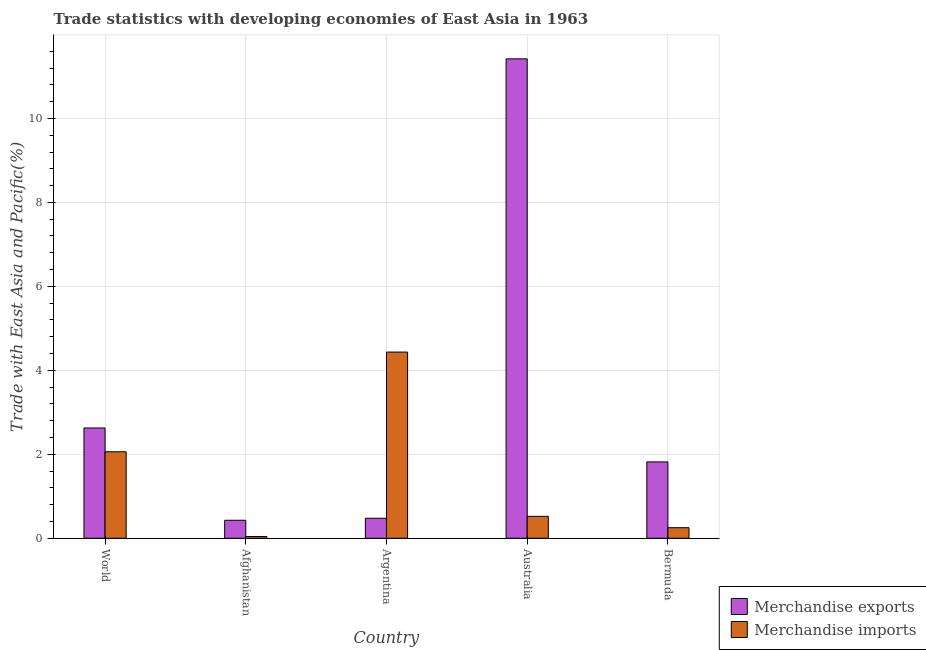How many groups of bars are there?
Offer a very short reply. 5. Are the number of bars on each tick of the X-axis equal?
Give a very brief answer. Yes. How many bars are there on the 2nd tick from the left?
Ensure brevity in your answer.  2. What is the label of the 2nd group of bars from the left?
Offer a terse response. Afghanistan. In how many cases, is the number of bars for a given country not equal to the number of legend labels?
Provide a short and direct response. 0. What is the merchandise imports in World?
Your answer should be compact. 2.06. Across all countries, what is the maximum merchandise exports?
Offer a terse response. 11.42. Across all countries, what is the minimum merchandise imports?
Ensure brevity in your answer.  0.04. In which country was the merchandise imports maximum?
Give a very brief answer. Argentina. In which country was the merchandise exports minimum?
Offer a terse response. Afghanistan. What is the total merchandise exports in the graph?
Your answer should be compact. 16.77. What is the difference between the merchandise imports in Afghanistan and that in Australia?
Your answer should be compact. -0.48. What is the difference between the merchandise exports in Australia and the merchandise imports in World?
Make the answer very short. 9.36. What is the average merchandise exports per country?
Offer a terse response. 3.35. What is the difference between the merchandise exports and merchandise imports in Bermuda?
Your response must be concise. 1.57. In how many countries, is the merchandise exports greater than 8 %?
Offer a terse response. 1. What is the ratio of the merchandise imports in Australia to that in World?
Your response must be concise. 0.25. Is the difference between the merchandise exports in Australia and World greater than the difference between the merchandise imports in Australia and World?
Your answer should be very brief. Yes. What is the difference between the highest and the second highest merchandise imports?
Offer a terse response. 2.38. What is the difference between the highest and the lowest merchandise exports?
Provide a short and direct response. 10.99. Is the sum of the merchandise imports in Australia and World greater than the maximum merchandise exports across all countries?
Make the answer very short. No. What does the 2nd bar from the right in Argentina represents?
Your response must be concise. Merchandise exports. Are all the bars in the graph horizontal?
Your answer should be very brief. No. How many countries are there in the graph?
Your answer should be very brief. 5. What is the difference between two consecutive major ticks on the Y-axis?
Your answer should be compact. 2. Does the graph contain grids?
Your answer should be compact. Yes. Where does the legend appear in the graph?
Ensure brevity in your answer.  Bottom right. How many legend labels are there?
Give a very brief answer. 2. What is the title of the graph?
Your answer should be very brief. Trade statistics with developing economies of East Asia in 1963. What is the label or title of the X-axis?
Ensure brevity in your answer.  Country. What is the label or title of the Y-axis?
Offer a terse response. Trade with East Asia and Pacific(%). What is the Trade with East Asia and Pacific(%) of Merchandise exports in World?
Make the answer very short. 2.63. What is the Trade with East Asia and Pacific(%) in Merchandise imports in World?
Offer a very short reply. 2.06. What is the Trade with East Asia and Pacific(%) of Merchandise exports in Afghanistan?
Offer a terse response. 0.43. What is the Trade with East Asia and Pacific(%) in Merchandise imports in Afghanistan?
Provide a short and direct response. 0.04. What is the Trade with East Asia and Pacific(%) of Merchandise exports in Argentina?
Keep it short and to the point. 0.48. What is the Trade with East Asia and Pacific(%) in Merchandise imports in Argentina?
Keep it short and to the point. 4.43. What is the Trade with East Asia and Pacific(%) in Merchandise exports in Australia?
Offer a terse response. 11.42. What is the Trade with East Asia and Pacific(%) of Merchandise imports in Australia?
Your response must be concise. 0.52. What is the Trade with East Asia and Pacific(%) in Merchandise exports in Bermuda?
Provide a succinct answer. 1.82. What is the Trade with East Asia and Pacific(%) in Merchandise imports in Bermuda?
Offer a terse response. 0.25. Across all countries, what is the maximum Trade with East Asia and Pacific(%) of Merchandise exports?
Ensure brevity in your answer.  11.42. Across all countries, what is the maximum Trade with East Asia and Pacific(%) of Merchandise imports?
Your answer should be very brief. 4.43. Across all countries, what is the minimum Trade with East Asia and Pacific(%) in Merchandise exports?
Your answer should be compact. 0.43. Across all countries, what is the minimum Trade with East Asia and Pacific(%) in Merchandise imports?
Your response must be concise. 0.04. What is the total Trade with East Asia and Pacific(%) in Merchandise exports in the graph?
Ensure brevity in your answer.  16.77. What is the total Trade with East Asia and Pacific(%) of Merchandise imports in the graph?
Your answer should be compact. 7.31. What is the difference between the Trade with East Asia and Pacific(%) of Merchandise exports in World and that in Afghanistan?
Your answer should be compact. 2.2. What is the difference between the Trade with East Asia and Pacific(%) of Merchandise imports in World and that in Afghanistan?
Give a very brief answer. 2.02. What is the difference between the Trade with East Asia and Pacific(%) in Merchandise exports in World and that in Argentina?
Offer a terse response. 2.15. What is the difference between the Trade with East Asia and Pacific(%) in Merchandise imports in World and that in Argentina?
Offer a very short reply. -2.38. What is the difference between the Trade with East Asia and Pacific(%) of Merchandise exports in World and that in Australia?
Give a very brief answer. -8.79. What is the difference between the Trade with East Asia and Pacific(%) in Merchandise imports in World and that in Australia?
Provide a short and direct response. 1.54. What is the difference between the Trade with East Asia and Pacific(%) in Merchandise exports in World and that in Bermuda?
Offer a terse response. 0.81. What is the difference between the Trade with East Asia and Pacific(%) of Merchandise imports in World and that in Bermuda?
Your response must be concise. 1.81. What is the difference between the Trade with East Asia and Pacific(%) of Merchandise exports in Afghanistan and that in Argentina?
Give a very brief answer. -0.05. What is the difference between the Trade with East Asia and Pacific(%) of Merchandise imports in Afghanistan and that in Argentina?
Your answer should be very brief. -4.39. What is the difference between the Trade with East Asia and Pacific(%) in Merchandise exports in Afghanistan and that in Australia?
Offer a terse response. -10.99. What is the difference between the Trade with East Asia and Pacific(%) in Merchandise imports in Afghanistan and that in Australia?
Ensure brevity in your answer.  -0.48. What is the difference between the Trade with East Asia and Pacific(%) of Merchandise exports in Afghanistan and that in Bermuda?
Your answer should be very brief. -1.39. What is the difference between the Trade with East Asia and Pacific(%) in Merchandise imports in Afghanistan and that in Bermuda?
Ensure brevity in your answer.  -0.21. What is the difference between the Trade with East Asia and Pacific(%) in Merchandise exports in Argentina and that in Australia?
Your answer should be compact. -10.94. What is the difference between the Trade with East Asia and Pacific(%) in Merchandise imports in Argentina and that in Australia?
Ensure brevity in your answer.  3.91. What is the difference between the Trade with East Asia and Pacific(%) of Merchandise exports in Argentina and that in Bermuda?
Your response must be concise. -1.34. What is the difference between the Trade with East Asia and Pacific(%) of Merchandise imports in Argentina and that in Bermuda?
Provide a succinct answer. 4.18. What is the difference between the Trade with East Asia and Pacific(%) of Merchandise exports in Australia and that in Bermuda?
Offer a very short reply. 9.6. What is the difference between the Trade with East Asia and Pacific(%) of Merchandise imports in Australia and that in Bermuda?
Provide a succinct answer. 0.27. What is the difference between the Trade with East Asia and Pacific(%) in Merchandise exports in World and the Trade with East Asia and Pacific(%) in Merchandise imports in Afghanistan?
Provide a succinct answer. 2.59. What is the difference between the Trade with East Asia and Pacific(%) in Merchandise exports in World and the Trade with East Asia and Pacific(%) in Merchandise imports in Argentina?
Keep it short and to the point. -1.81. What is the difference between the Trade with East Asia and Pacific(%) in Merchandise exports in World and the Trade with East Asia and Pacific(%) in Merchandise imports in Australia?
Offer a terse response. 2.1. What is the difference between the Trade with East Asia and Pacific(%) of Merchandise exports in World and the Trade with East Asia and Pacific(%) of Merchandise imports in Bermuda?
Offer a terse response. 2.38. What is the difference between the Trade with East Asia and Pacific(%) of Merchandise exports in Afghanistan and the Trade with East Asia and Pacific(%) of Merchandise imports in Argentina?
Your response must be concise. -4.01. What is the difference between the Trade with East Asia and Pacific(%) in Merchandise exports in Afghanistan and the Trade with East Asia and Pacific(%) in Merchandise imports in Australia?
Your response must be concise. -0.09. What is the difference between the Trade with East Asia and Pacific(%) of Merchandise exports in Afghanistan and the Trade with East Asia and Pacific(%) of Merchandise imports in Bermuda?
Offer a very short reply. 0.18. What is the difference between the Trade with East Asia and Pacific(%) in Merchandise exports in Argentina and the Trade with East Asia and Pacific(%) in Merchandise imports in Australia?
Your answer should be compact. -0.05. What is the difference between the Trade with East Asia and Pacific(%) of Merchandise exports in Argentina and the Trade with East Asia and Pacific(%) of Merchandise imports in Bermuda?
Your answer should be compact. 0.23. What is the difference between the Trade with East Asia and Pacific(%) in Merchandise exports in Australia and the Trade with East Asia and Pacific(%) in Merchandise imports in Bermuda?
Provide a succinct answer. 11.17. What is the average Trade with East Asia and Pacific(%) in Merchandise exports per country?
Offer a terse response. 3.35. What is the average Trade with East Asia and Pacific(%) in Merchandise imports per country?
Your answer should be very brief. 1.46. What is the difference between the Trade with East Asia and Pacific(%) of Merchandise exports and Trade with East Asia and Pacific(%) of Merchandise imports in World?
Provide a succinct answer. 0.57. What is the difference between the Trade with East Asia and Pacific(%) of Merchandise exports and Trade with East Asia and Pacific(%) of Merchandise imports in Afghanistan?
Your answer should be very brief. 0.39. What is the difference between the Trade with East Asia and Pacific(%) in Merchandise exports and Trade with East Asia and Pacific(%) in Merchandise imports in Argentina?
Offer a very short reply. -3.96. What is the difference between the Trade with East Asia and Pacific(%) in Merchandise exports and Trade with East Asia and Pacific(%) in Merchandise imports in Australia?
Keep it short and to the point. 10.9. What is the difference between the Trade with East Asia and Pacific(%) in Merchandise exports and Trade with East Asia and Pacific(%) in Merchandise imports in Bermuda?
Keep it short and to the point. 1.57. What is the ratio of the Trade with East Asia and Pacific(%) in Merchandise exports in World to that in Afghanistan?
Your response must be concise. 6.14. What is the ratio of the Trade with East Asia and Pacific(%) in Merchandise imports in World to that in Afghanistan?
Give a very brief answer. 49.97. What is the ratio of the Trade with East Asia and Pacific(%) in Merchandise exports in World to that in Argentina?
Keep it short and to the point. 5.51. What is the ratio of the Trade with East Asia and Pacific(%) in Merchandise imports in World to that in Argentina?
Your answer should be compact. 0.46. What is the ratio of the Trade with East Asia and Pacific(%) in Merchandise exports in World to that in Australia?
Provide a short and direct response. 0.23. What is the ratio of the Trade with East Asia and Pacific(%) in Merchandise imports in World to that in Australia?
Make the answer very short. 3.94. What is the ratio of the Trade with East Asia and Pacific(%) in Merchandise exports in World to that in Bermuda?
Your answer should be compact. 1.44. What is the ratio of the Trade with East Asia and Pacific(%) of Merchandise imports in World to that in Bermuda?
Give a very brief answer. 8.2. What is the ratio of the Trade with East Asia and Pacific(%) in Merchandise exports in Afghanistan to that in Argentina?
Offer a very short reply. 0.9. What is the ratio of the Trade with East Asia and Pacific(%) in Merchandise imports in Afghanistan to that in Argentina?
Your answer should be very brief. 0.01. What is the ratio of the Trade with East Asia and Pacific(%) in Merchandise exports in Afghanistan to that in Australia?
Ensure brevity in your answer.  0.04. What is the ratio of the Trade with East Asia and Pacific(%) in Merchandise imports in Afghanistan to that in Australia?
Offer a terse response. 0.08. What is the ratio of the Trade with East Asia and Pacific(%) in Merchandise exports in Afghanistan to that in Bermuda?
Make the answer very short. 0.24. What is the ratio of the Trade with East Asia and Pacific(%) of Merchandise imports in Afghanistan to that in Bermuda?
Provide a short and direct response. 0.16. What is the ratio of the Trade with East Asia and Pacific(%) in Merchandise exports in Argentina to that in Australia?
Keep it short and to the point. 0.04. What is the ratio of the Trade with East Asia and Pacific(%) in Merchandise imports in Argentina to that in Australia?
Your answer should be compact. 8.49. What is the ratio of the Trade with East Asia and Pacific(%) in Merchandise exports in Argentina to that in Bermuda?
Your answer should be very brief. 0.26. What is the ratio of the Trade with East Asia and Pacific(%) of Merchandise imports in Argentina to that in Bermuda?
Make the answer very short. 17.66. What is the ratio of the Trade with East Asia and Pacific(%) in Merchandise exports in Australia to that in Bermuda?
Offer a terse response. 6.28. What is the ratio of the Trade with East Asia and Pacific(%) of Merchandise imports in Australia to that in Bermuda?
Give a very brief answer. 2.08. What is the difference between the highest and the second highest Trade with East Asia and Pacific(%) of Merchandise exports?
Offer a terse response. 8.79. What is the difference between the highest and the second highest Trade with East Asia and Pacific(%) of Merchandise imports?
Provide a succinct answer. 2.38. What is the difference between the highest and the lowest Trade with East Asia and Pacific(%) of Merchandise exports?
Offer a terse response. 10.99. What is the difference between the highest and the lowest Trade with East Asia and Pacific(%) in Merchandise imports?
Your answer should be compact. 4.39. 